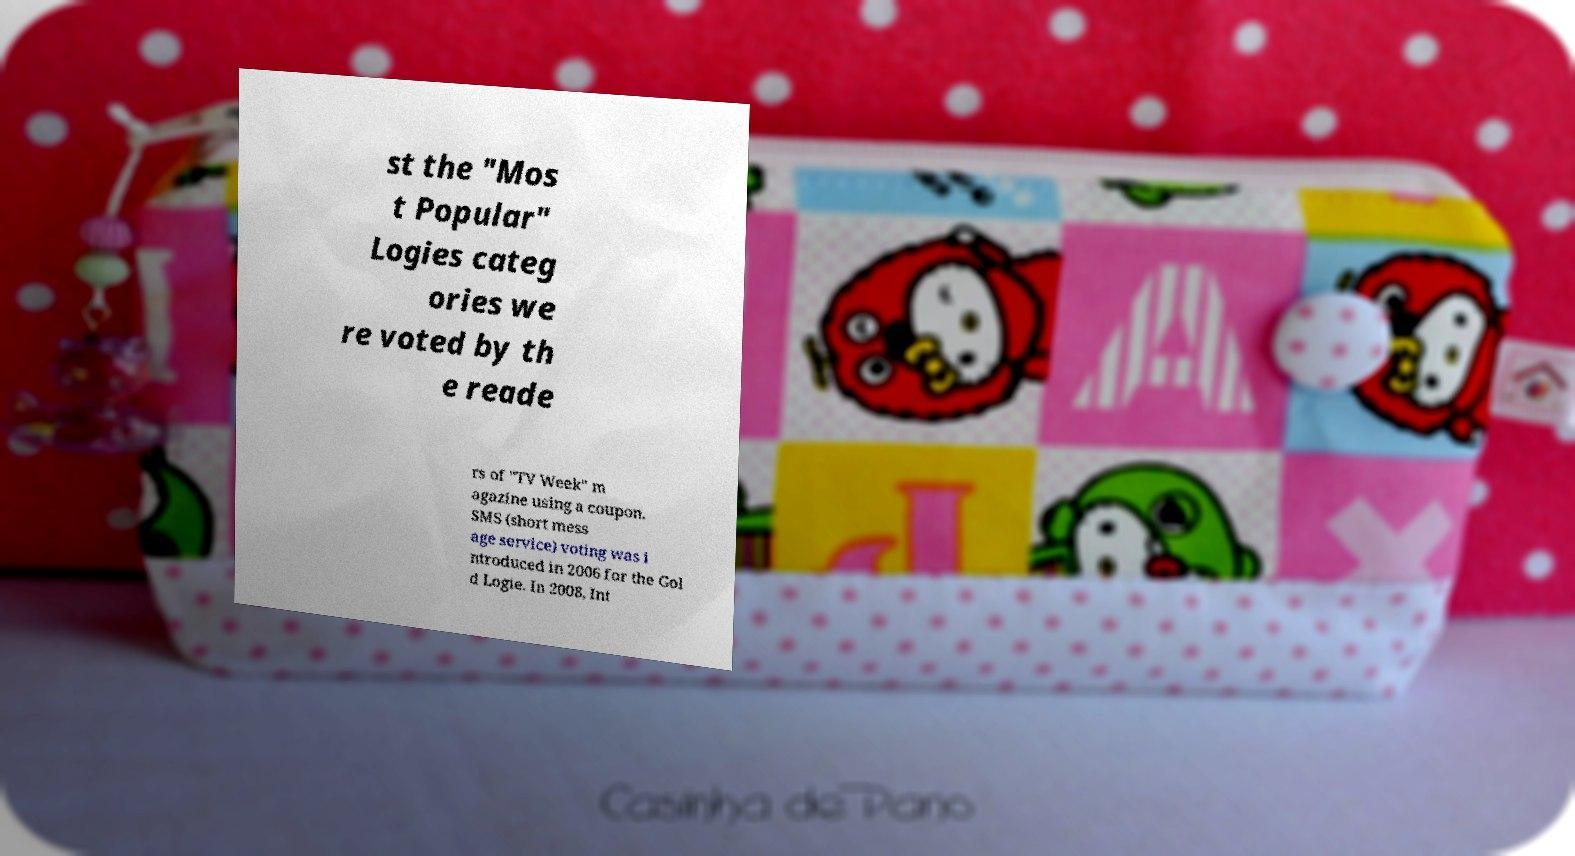Could you assist in decoding the text presented in this image and type it out clearly? st the "Mos t Popular" Logies categ ories we re voted by th e reade rs of "TV Week" m agazine using a coupon. SMS (short mess age service) voting was i ntroduced in 2006 for the Gol d Logie. In 2008, Int 